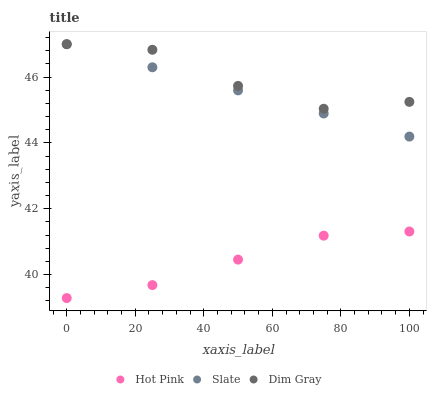Does Hot Pink have the minimum area under the curve?
Answer yes or no. Yes. Does Dim Gray have the maximum area under the curve?
Answer yes or no. Yes. Does Dim Gray have the minimum area under the curve?
Answer yes or no. No. Does Hot Pink have the maximum area under the curve?
Answer yes or no. No. Is Slate the smoothest?
Answer yes or no. Yes. Is Dim Gray the roughest?
Answer yes or no. Yes. Is Hot Pink the smoothest?
Answer yes or no. No. Is Hot Pink the roughest?
Answer yes or no. No. Does Hot Pink have the lowest value?
Answer yes or no. Yes. Does Dim Gray have the lowest value?
Answer yes or no. No. Does Dim Gray have the highest value?
Answer yes or no. Yes. Does Hot Pink have the highest value?
Answer yes or no. No. Is Hot Pink less than Slate?
Answer yes or no. Yes. Is Slate greater than Hot Pink?
Answer yes or no. Yes. Does Dim Gray intersect Slate?
Answer yes or no. Yes. Is Dim Gray less than Slate?
Answer yes or no. No. Is Dim Gray greater than Slate?
Answer yes or no. No. Does Hot Pink intersect Slate?
Answer yes or no. No. 